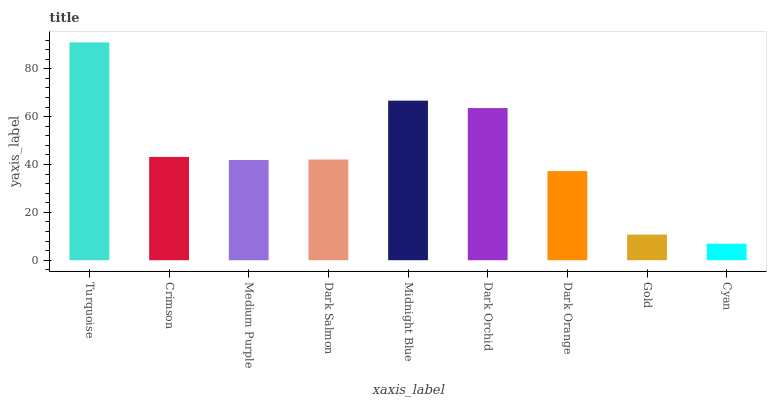Is Crimson the minimum?
Answer yes or no. No. Is Crimson the maximum?
Answer yes or no. No. Is Turquoise greater than Crimson?
Answer yes or no. Yes. Is Crimson less than Turquoise?
Answer yes or no. Yes. Is Crimson greater than Turquoise?
Answer yes or no. No. Is Turquoise less than Crimson?
Answer yes or no. No. Is Dark Salmon the high median?
Answer yes or no. Yes. Is Dark Salmon the low median?
Answer yes or no. Yes. Is Dark Orange the high median?
Answer yes or no. No. Is Gold the low median?
Answer yes or no. No. 